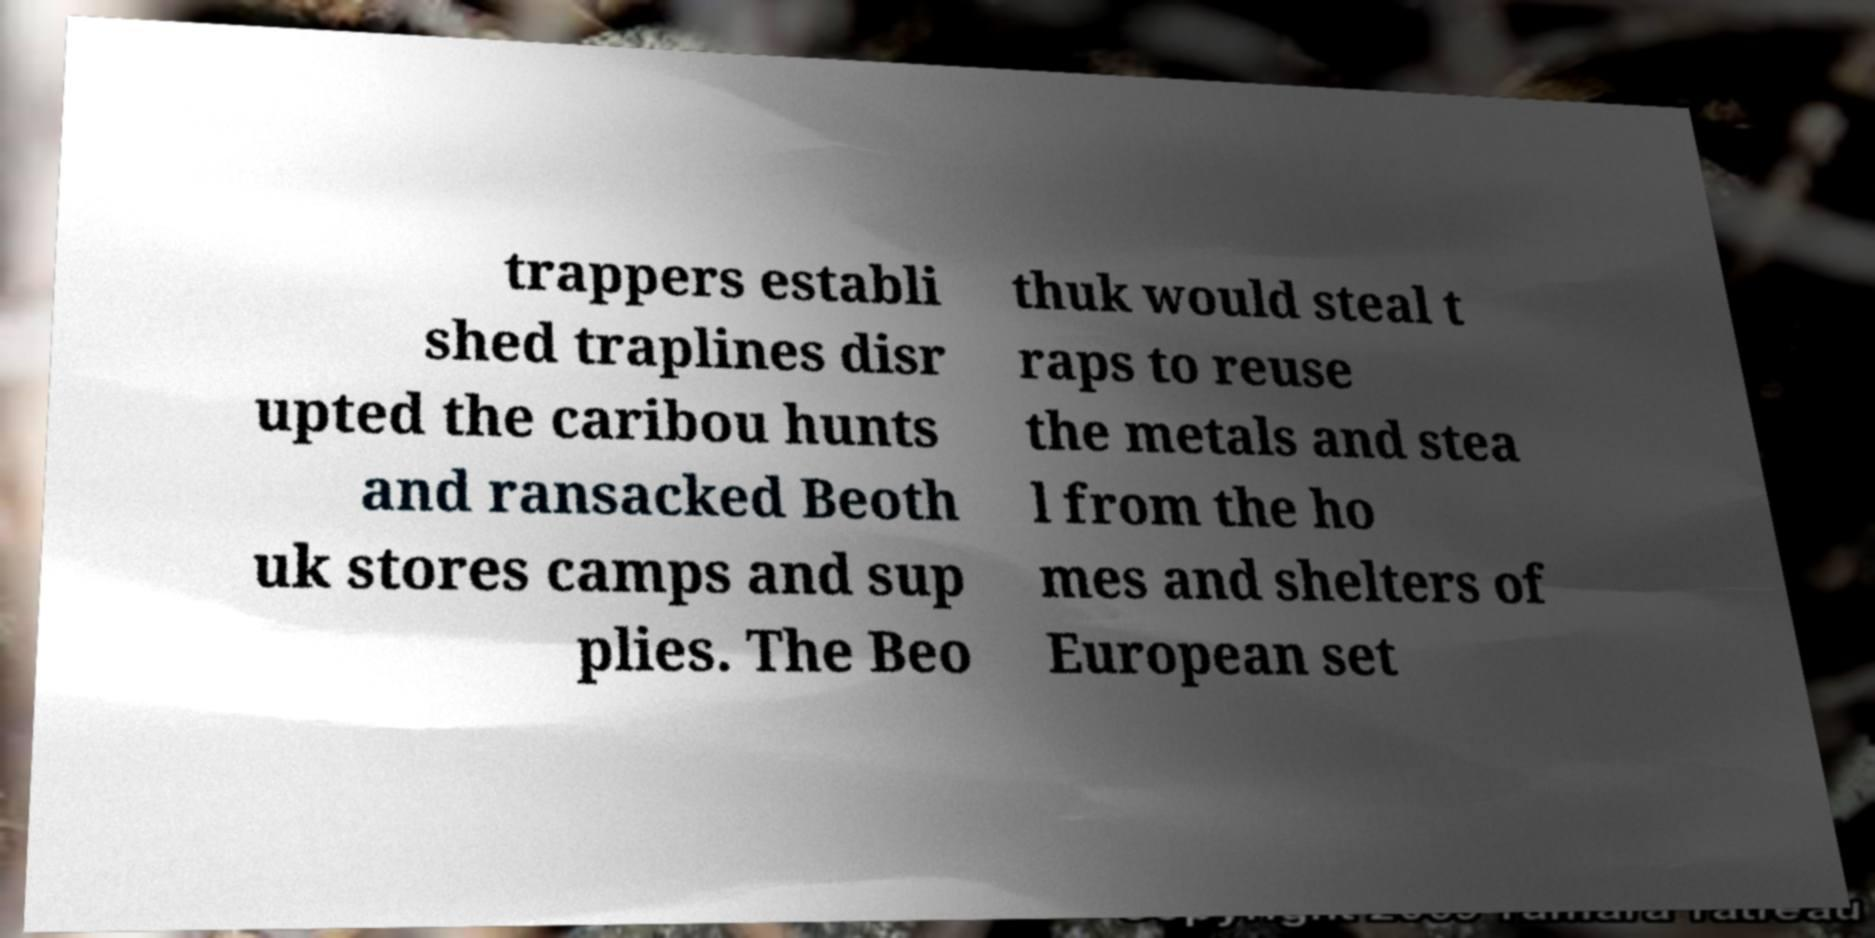Please read and relay the text visible in this image. What does it say? trappers establi shed traplines disr upted the caribou hunts and ransacked Beoth uk stores camps and sup plies. The Beo thuk would steal t raps to reuse the metals and stea l from the ho mes and shelters of European set 